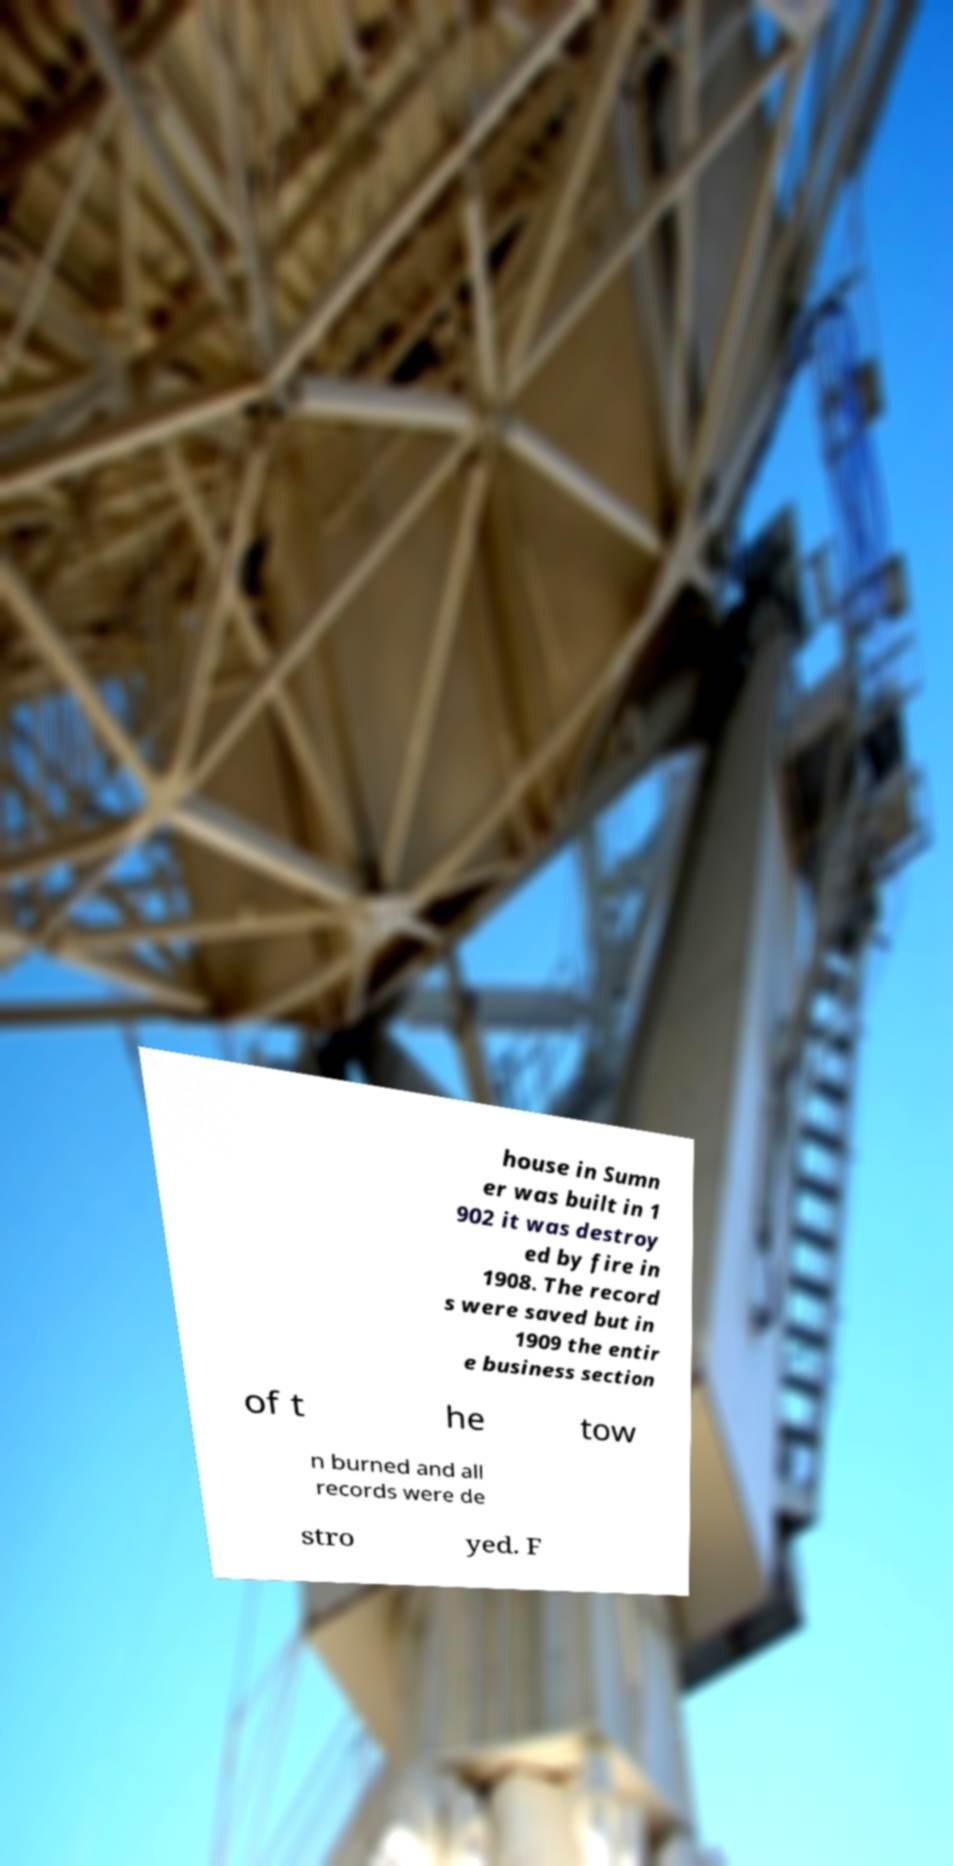Could you extract and type out the text from this image? house in Sumn er was built in 1 902 it was destroy ed by fire in 1908. The record s were saved but in 1909 the entir e business section of t he tow n burned and all records were de stro yed. F 